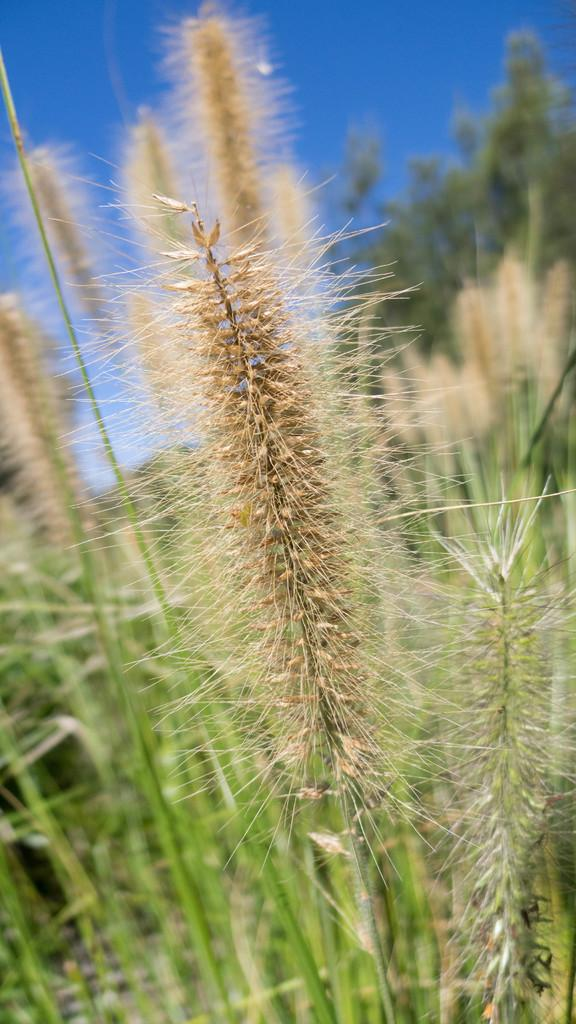What type of living organisms can be seen in the image? Plants can be seen in the image. What part of the natural environment is visible in the image? The sky is visible in the background of the image. What brand of toothpaste is being advertised in the image? There is no toothpaste or advertisement present in the image; it features plants and the sky. 